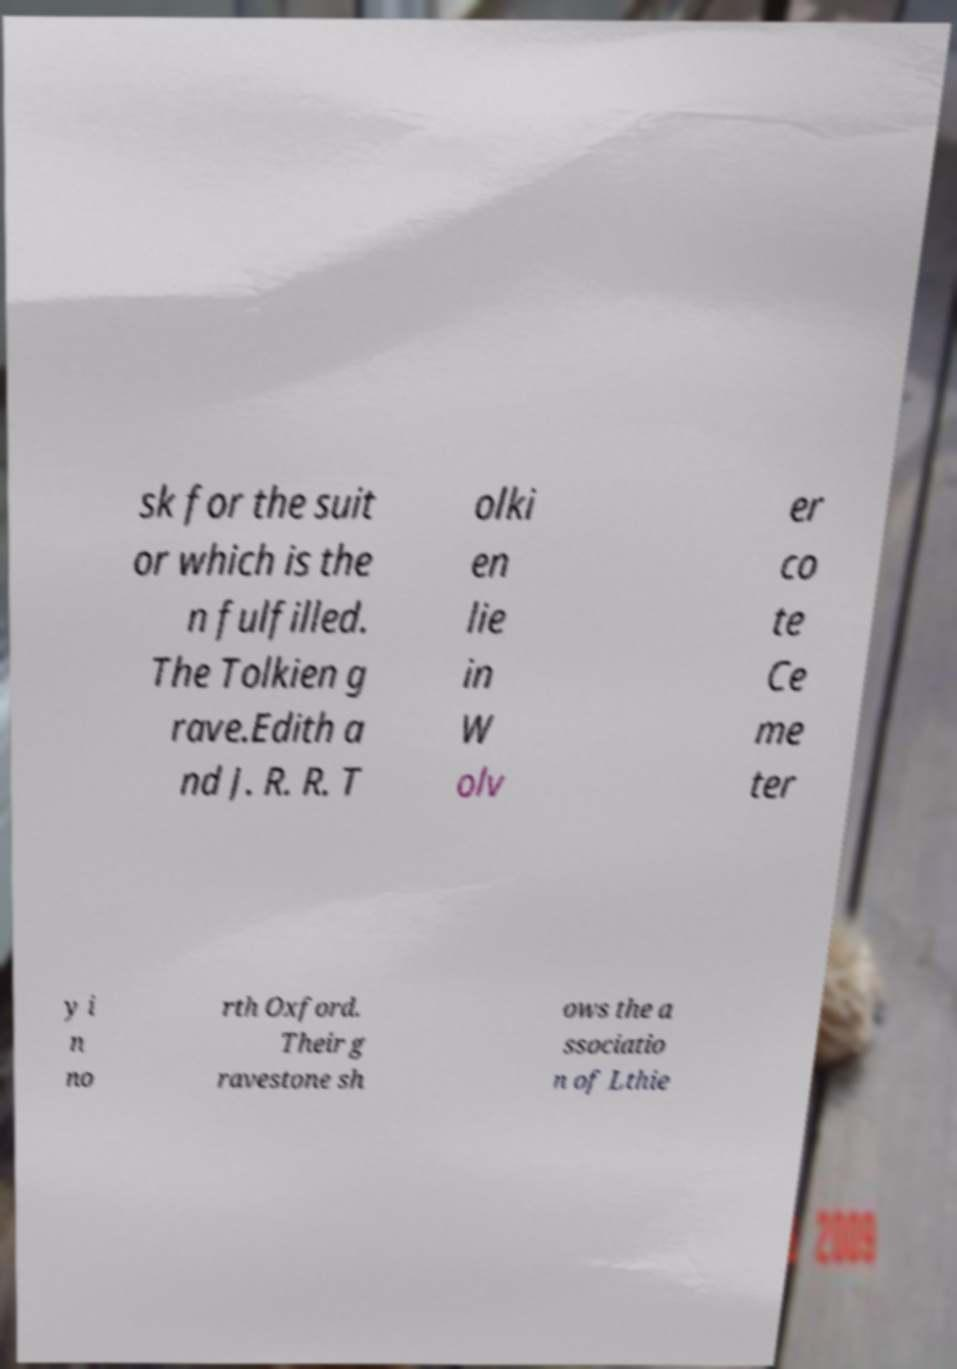Could you extract and type out the text from this image? sk for the suit or which is the n fulfilled. The Tolkien g rave.Edith a nd J. R. R. T olki en lie in W olv er co te Ce me ter y i n no rth Oxford. Their g ravestone sh ows the a ssociatio n of Lthie 